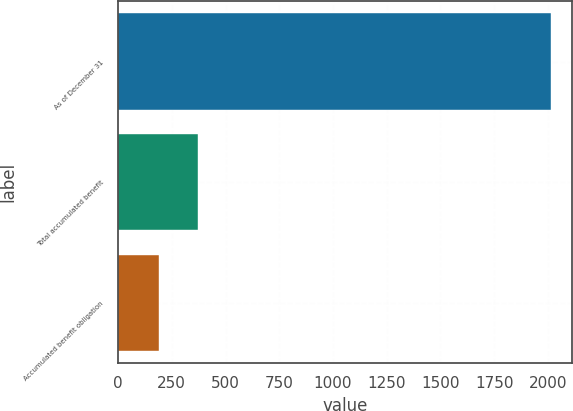Convert chart to OTSL. <chart><loc_0><loc_0><loc_500><loc_500><bar_chart><fcel>As of December 31<fcel>Total accumulated benefit<fcel>Accumulated benefit obligation<nl><fcel>2012<fcel>373.91<fcel>191.9<nl></chart> 